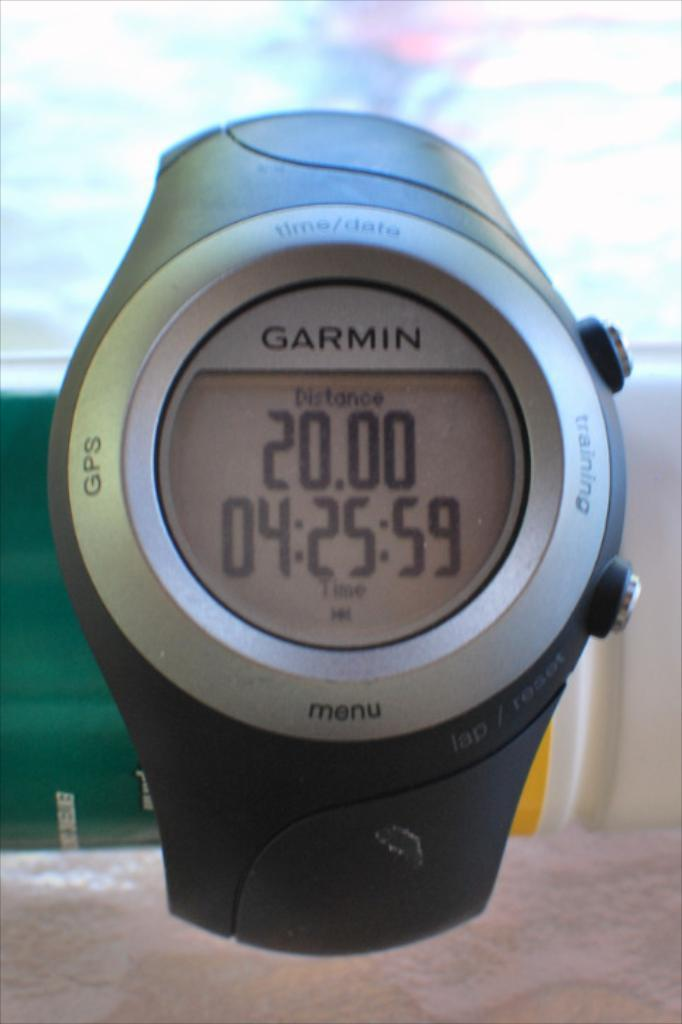<image>
Summarize the visual content of the image. A Garmin watch shows the distance and time left. 